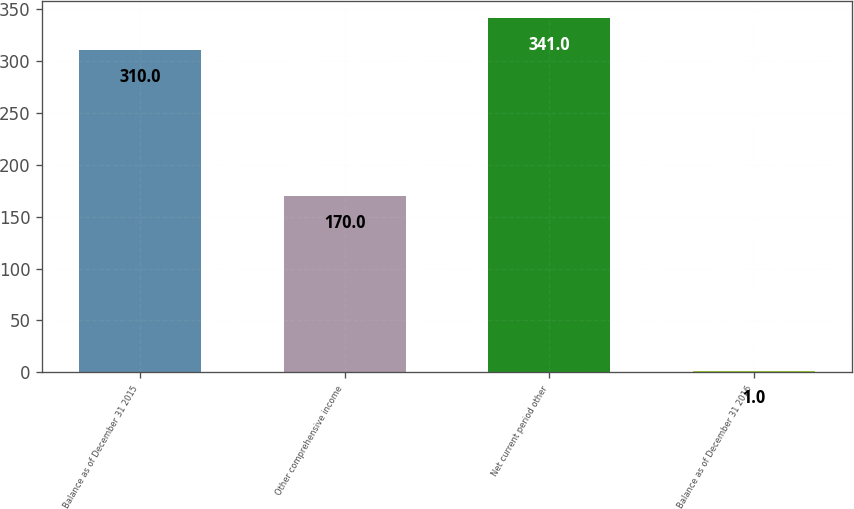<chart> <loc_0><loc_0><loc_500><loc_500><bar_chart><fcel>Balance as of December 31 2015<fcel>Other comprehensive income<fcel>Net current period other<fcel>Balance as of December 31 2016<nl><fcel>310<fcel>170<fcel>341<fcel>1<nl></chart> 